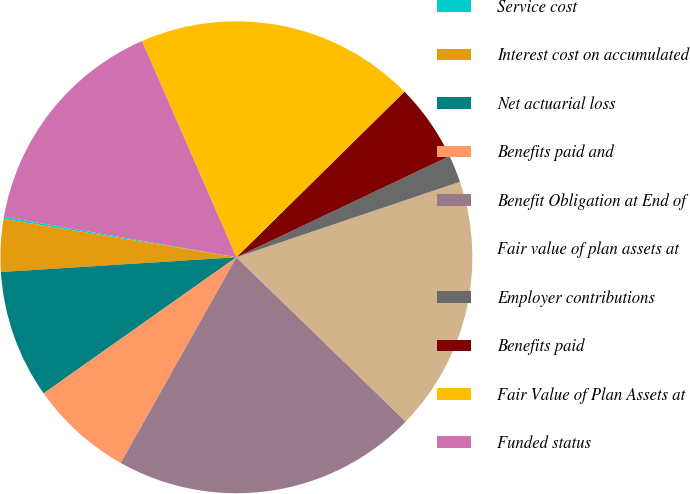Convert chart. <chart><loc_0><loc_0><loc_500><loc_500><pie_chart><fcel>Service cost<fcel>Interest cost on accumulated<fcel>Net actuarial loss<fcel>Benefits paid and<fcel>Benefit Obligation at End of<fcel>Fair value of plan assets at<fcel>Employer contributions<fcel>Benefits paid<fcel>Fair Value of Plan Assets at<fcel>Funded status<nl><fcel>0.14%<fcel>3.6%<fcel>8.79%<fcel>7.06%<fcel>20.9%<fcel>17.44%<fcel>1.87%<fcel>5.33%<fcel>19.17%<fcel>15.71%<nl></chart> 